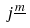<formula> <loc_0><loc_0><loc_500><loc_500>j ^ { \underline { m } }</formula> 